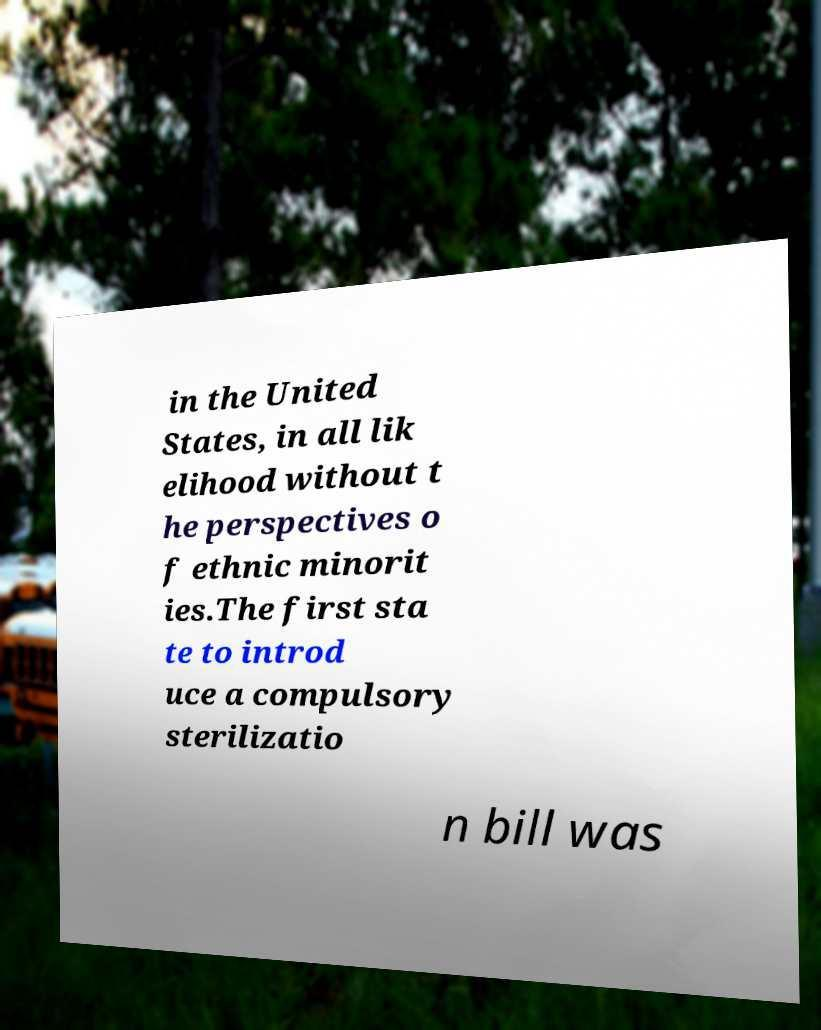There's text embedded in this image that I need extracted. Can you transcribe it verbatim? in the United States, in all lik elihood without t he perspectives o f ethnic minorit ies.The first sta te to introd uce a compulsory sterilizatio n bill was 